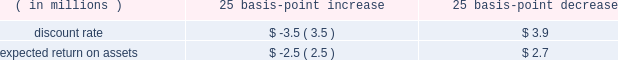We also record an inventory obsolescence reserve , which represents the difference between the cost of the inventory and its estimated realizable value , based on various product sales projections .
This reserve is calcu- lated using an estimated obsolescence percentage applied to the inventory based on age , historical trends and requirements to support forecasted sales .
In addition , and as necessary , we may establish specific reserves for future known or anticipated events .
Pension and other post-retirement benefit costs we offer the following benefits to some or all of our employees : a domestic trust-based noncontributory qual- ified defined benefit pension plan ( 201cu.s .
Qualified plan 201d ) and an unfunded , non-qualified domestic noncon- tributory pension plan to provide benefits in excess of statutory limitations ( collectively with the u.s .
Qualified plan , the 201cdomestic plans 201d ) ; a domestic contributory defined contribution plan ; international pension plans , which vary by country , consisting of both defined benefit and defined contribution pension plans ; deferred compensation arrangements ; and certain other post- retirement benefit plans .
The amounts needed to fund future payouts under our defined benefit pension and post-retirement benefit plans are subject to numerous assumptions and variables .
Cer- tain significant variables require us to make assumptions that are within our control such as an anticipated discount rate , expected rate of return on plan assets and future compensation levels .
We evaluate these assumptions with our actuarial advisors and select assumptions that we believe reflect the economics underlying our pension and post-retirement obligations .
While we believe these assumptions are within accepted industry ranges , an increase or decrease in the assumptions or economic events outside our control could have a direct impact on reported net earnings .
The discount rate for each plan used for determining future net periodic benefit cost is based on a review of highly rated long-term bonds .
For fiscal 2013 , we used a discount rate for our domestic plans of 3.90% ( 3.90 % ) and vary- ing rates on our international plans of between 1.00% ( 1.00 % ) and 7.00% ( 7.00 % ) .
The discount rate for our domestic plans is based on a bond portfolio that includes only long-term bonds with an aa rating , or equivalent , from a major rating agency .
As of june 30 , 2013 , we used an above-mean yield curve , rather than the broad-based yield curve we used before , because we believe it represents a better estimate of an effective settlement rate of the obligation , and the timing and amount of cash flows related to the bonds included in this portfolio are expected to match the estimated defined benefit payment streams of our domestic plans .
The benefit obligation of our domestic plans would have been higher by approximately $ 34 mil- lion at june 30 , 2013 had we not used the above-mean yield curve .
For our international plans , the discount rate in a particular country was principally determined based on a yield curve constructed from high quality corporate bonds in each country , with the resulting portfolio having a duration matching that particular plan .
For fiscal 2013 , we used an expected return on plan assets of 7.50% ( 7.50 % ) for our u.s .
Qualified plan and varying rates of between 2.25% ( 2.25 % ) and 7.00% ( 7.00 % ) for our international plans .
In determining the long-term rate of return for a plan , we consider the historical rates of return , the nature of the plan 2019s investments and an expectation for the plan 2019s investment strategies .
See 201cnote 12 2014 pension , deferred compensation and post-retirement benefit plans 201d of notes to consolidated financial statements for details regarding the nature of our pension and post-retirement plan invest- ments .
The difference between actual and expected return on plan assets is reported as a component of accu- mulated other comprehensive income .
Those gains/losses that are subject to amortization over future periods will be recognized as a component of the net periodic benefit cost in such future periods .
For fiscal 2013 , our pension plans had actual return on assets of approximately $ 74 million as compared with expected return on assets of approximately $ 64 million .
The resulting net deferred gain of approximately $ 10 million , when combined with gains and losses from previous years , will be amortized over periods ranging from approximately 7 to 22 years .
The actual return on plan assets from our international pen- sion plans exceeded expectations , primarily reflecting a strong performance from fixed income and equity invest- ments .
The lower than expected return on assets from our u.s .
Qualified plan was primarily due to weakness in our fixed income investments , partially offset by our strong equity returns .
A 25 basis-point change in the discount rate or the expected rate of return on plan assets would have had the following effect on fiscal 2013 pension expense : 25 basis-point 25 basis-point increase decrease ( in millions ) .
Our post-retirement plans are comprised of health care plans that could be impacted by health care cost trend rates , which may have a significant effect on the amounts the est{e lauder companies inc .
115 .
Considering the year 2013 , what was the percentual increase in the actual return on assets compared with the expected return? 
Rationale: it is the actual return divided by the expected return , then subtracted 1 and turned into a percentage .
Computations: ((74 / 64) - 1)
Answer: 0.15625. 